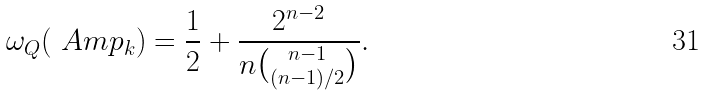Convert formula to latex. <formula><loc_0><loc_0><loc_500><loc_500>\omega _ { Q } ( \ A m p _ { k } ) = \frac { 1 } { 2 } + \frac { 2 ^ { n - 2 } } { n { n - 1 \choose ( n - 1 ) / 2 } } .</formula> 